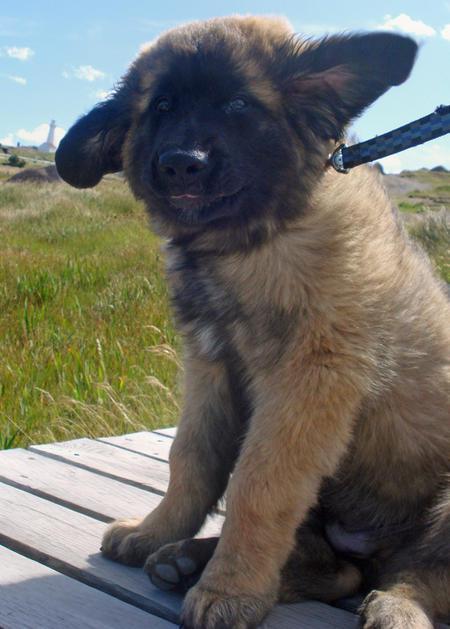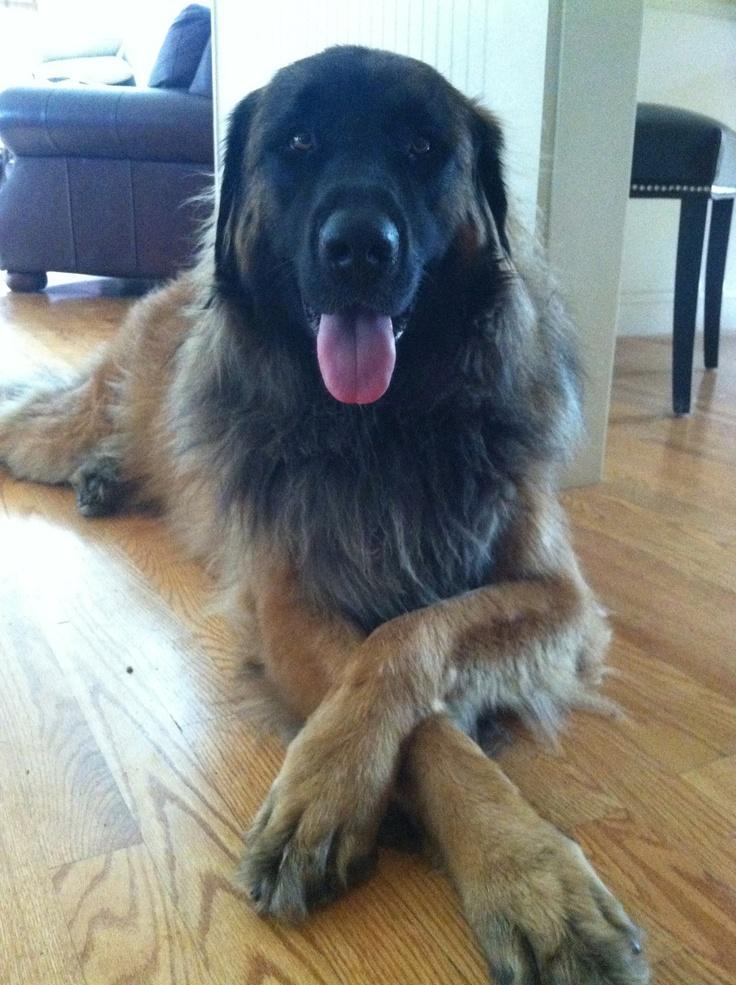The first image is the image on the left, the second image is the image on the right. For the images shown, is this caption "There are three dogs in one of the images." true? Answer yes or no. No. The first image is the image on the left, the second image is the image on the right. Considering the images on both sides, is "There's at least one human petting a dog." valid? Answer yes or no. No. 